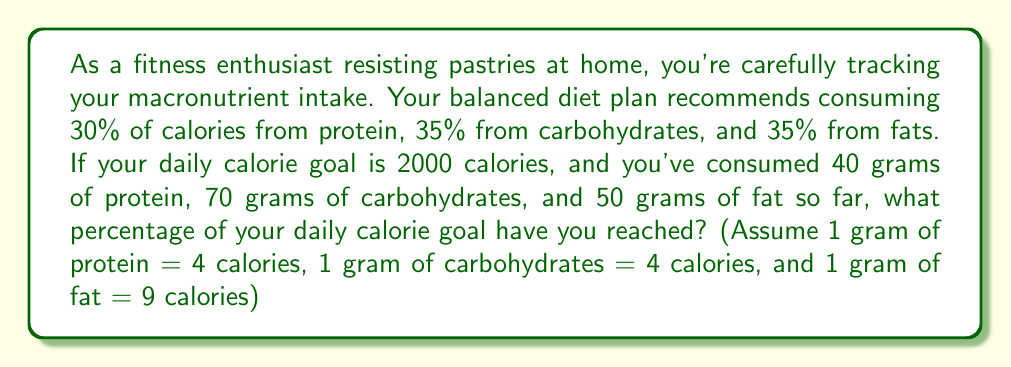Could you help me with this problem? Let's break this down step-by-step:

1) First, calculate the calories from each macronutrient:
   Protein: $40 \text{ g} \times 4 \text{ cal/g} = 160 \text{ cal}$
   Carbohydrates: $70 \text{ g} \times 4 \text{ cal/g} = 280 \text{ cal}$
   Fat: $50 \text{ g} \times 9 \text{ cal/g} = 450 \text{ cal}$

2) Calculate the total calories consumed:
   $\text{Total calories} = 160 + 280 + 450 = 890 \text{ cal}$

3) To find the percentage of daily calorie goal reached, divide the calories consumed by the daily goal and multiply by 100:

   $$\text{Percentage} = \frac{\text{Calories consumed}}{\text{Daily calorie goal}} \times 100\%$$
   
   $$= \frac{890}{2000} \times 100\% = 0.445 \times 100\% = 44.5\%$$

Therefore, you've reached 44.5% of your daily calorie goal.
Answer: 44.5% 